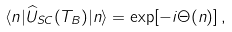Convert formula to latex. <formula><loc_0><loc_0><loc_500><loc_500>\langle { n } | \widehat { U } _ { S C } ( T _ { B } ) | { n } \rangle = \exp [ - i \Theta ( { n } ) ] \, ,</formula> 